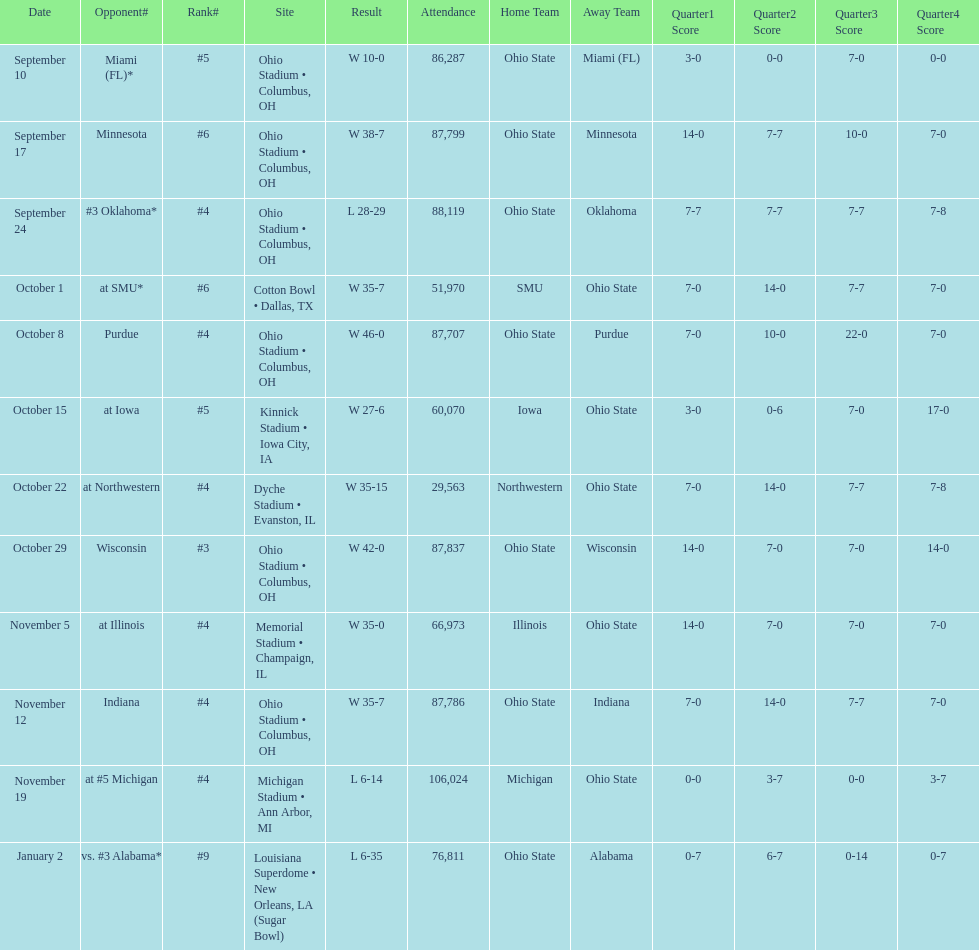Give me the full table as a dictionary. {'header': ['Date', 'Opponent#', 'Rank#', 'Site', 'Result', 'Attendance', 'Home Team', 'Away Team', 'Quarter1 Score', 'Quarter2 Score', 'Quarter3 Score', 'Quarter4 Score'], 'rows': [['September 10', 'Miami (FL)*', '#5', 'Ohio Stadium • Columbus, OH', 'W\xa010-0', '86,287', 'Ohio State', 'Miami (FL)', '3-0', '0-0', '7-0', '0-0'], ['September 17', 'Minnesota', '#6', 'Ohio Stadium • Columbus, OH', 'W\xa038-7', '87,799', 'Ohio State', 'Minnesota', '14-0', '7-7', '10-0', '7-0'], ['September 24', '#3\xa0Oklahoma*', '#4', 'Ohio Stadium • Columbus, OH', 'L\xa028-29', '88,119', 'Ohio State', 'Oklahoma', '7-7', '7-7', '7-7', '7-8'], ['October 1', 'at\xa0SMU*', '#6', 'Cotton Bowl • Dallas, TX', 'W\xa035-7', '51,970', 'SMU', 'Ohio State', '7-0', '14-0', '7-7', '7-0'], ['October 8', 'Purdue', '#4', 'Ohio Stadium • Columbus, OH', 'W\xa046-0', '87,707', 'Ohio State', 'Purdue', '7-0', '10-0', '22-0', '7-0'], ['October 15', 'at\xa0Iowa', '#5', 'Kinnick Stadium • Iowa City, IA', 'W\xa027-6', '60,070', 'Iowa', 'Ohio State', '3-0', '0-6', '7-0', '17-0'], ['October 22', 'at\xa0Northwestern', '#4', 'Dyche Stadium • Evanston, IL', 'W\xa035-15', '29,563', 'Northwestern', 'Ohio State', '7-0', '14-0', '7-7', '7-8'], ['October 29', 'Wisconsin', '#3', 'Ohio Stadium • Columbus, OH', 'W\xa042-0', '87,837', 'Ohio State', 'Wisconsin', '14-0', '7-0', '7-0', '14-0'], ['November 5', 'at\xa0Illinois', '#4', 'Memorial Stadium • Champaign, IL', 'W\xa035-0', '66,973', 'Illinois', 'Ohio State', '14-0', '7-0', '7-0', '7-0'], ['November 12', 'Indiana', '#4', 'Ohio Stadium • Columbus, OH', 'W\xa035-7', '87,786', 'Ohio State', 'Indiana', '7-0', '14-0', '7-7', '7-0'], ['November 19', 'at\xa0#5\xa0Michigan', '#4', 'Michigan Stadium • Ann Arbor, MI', 'L\xa06-14', '106,024', 'Michigan', 'Ohio State', '0-0', '3-7', '0-0', '3-7'], ['January 2', 'vs.\xa0#3\xa0Alabama*', '#9', 'Louisiana Superdome • New Orleans, LA (Sugar Bowl)', 'L\xa06-35', '76,811', 'Ohio State', 'Alabama', '0-7', '6-7', '0-14', '0-7']]} In how many games were than more than 80,000 people attending 7. 